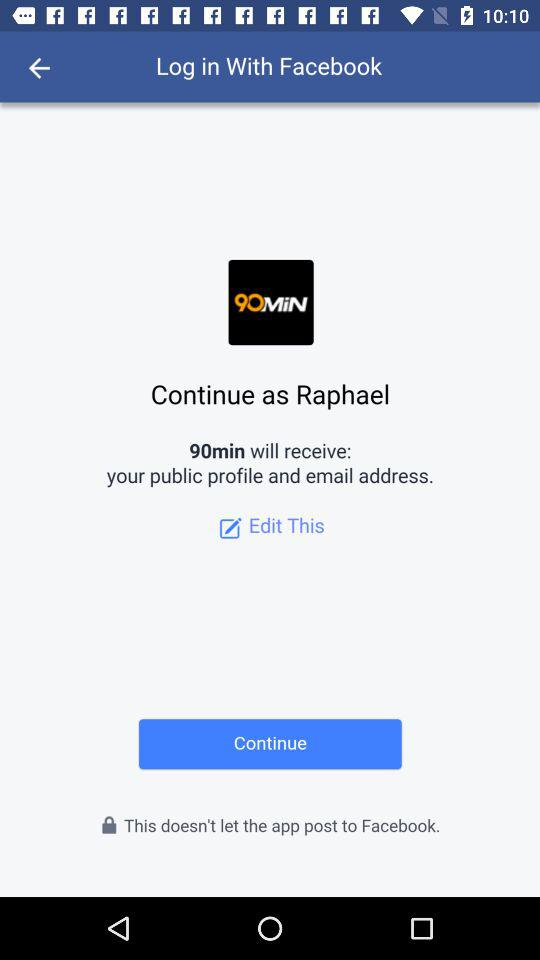Who is the application powered by?
When the provided information is insufficient, respond with <no answer>. <no answer> 